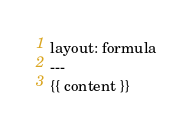<code> <loc_0><loc_0><loc_500><loc_500><_HTML_>layout: formula
---
{{ content }}
</code> 